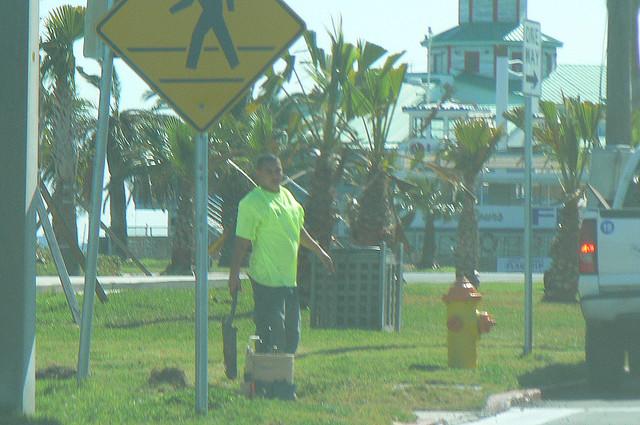What color is the man's shirt?
Keep it brief. Green. What kind of trees are in the park?
Answer briefly. Palm. Why is that man there?
Keep it brief. Working. 